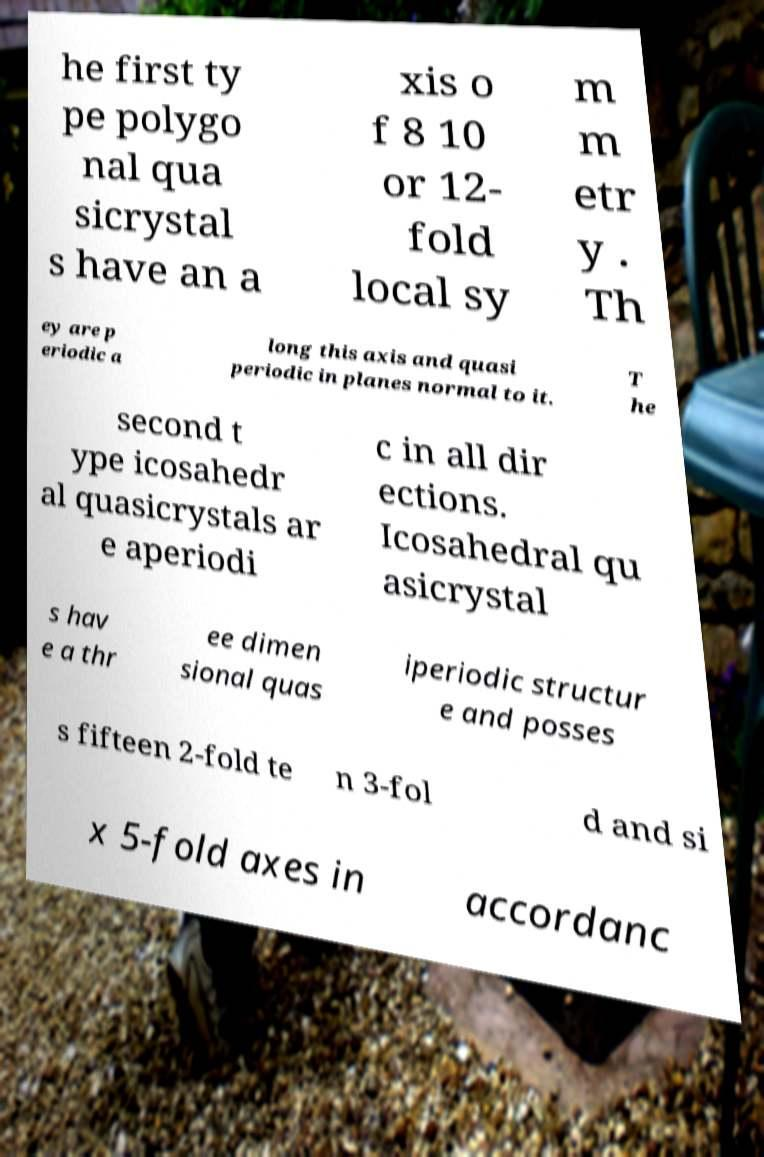Could you assist in decoding the text presented in this image and type it out clearly? he first ty pe polygo nal qua sicrystal s have an a xis o f 8 10 or 12- fold local sy m m etr y . Th ey are p eriodic a long this axis and quasi periodic in planes normal to it. T he second t ype icosahedr al quasicrystals ar e aperiodi c in all dir ections. Icosahedral qu asicrystal s hav e a thr ee dimen sional quas iperiodic structur e and posses s fifteen 2-fold te n 3-fol d and si x 5-fold axes in accordanc 